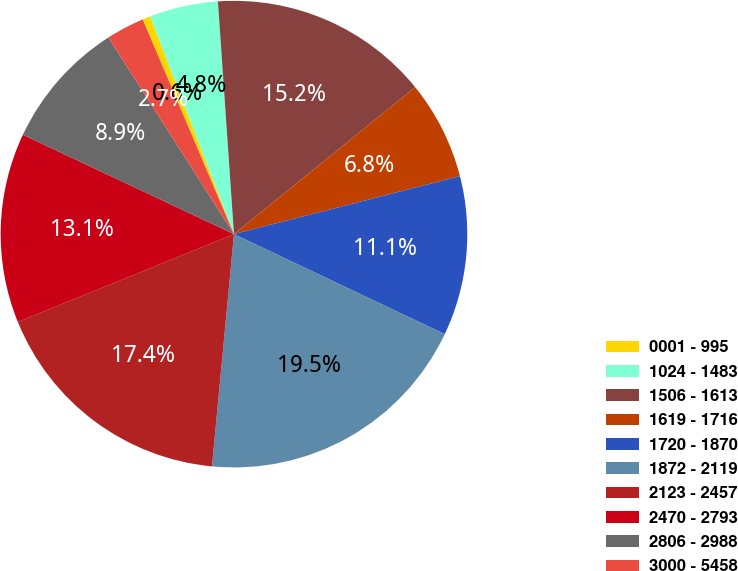Convert chart to OTSL. <chart><loc_0><loc_0><loc_500><loc_500><pie_chart><fcel>0001 - 995<fcel>1024 - 1483<fcel>1506 - 1613<fcel>1619 - 1716<fcel>1720 - 1870<fcel>1872 - 2119<fcel>2123 - 2457<fcel>2470 - 2793<fcel>2806 - 2988<fcel>3000 - 5458<nl><fcel>0.55%<fcel>4.75%<fcel>15.25%<fcel>6.85%<fcel>11.05%<fcel>19.45%<fcel>17.35%<fcel>13.15%<fcel>8.95%<fcel>2.65%<nl></chart> 